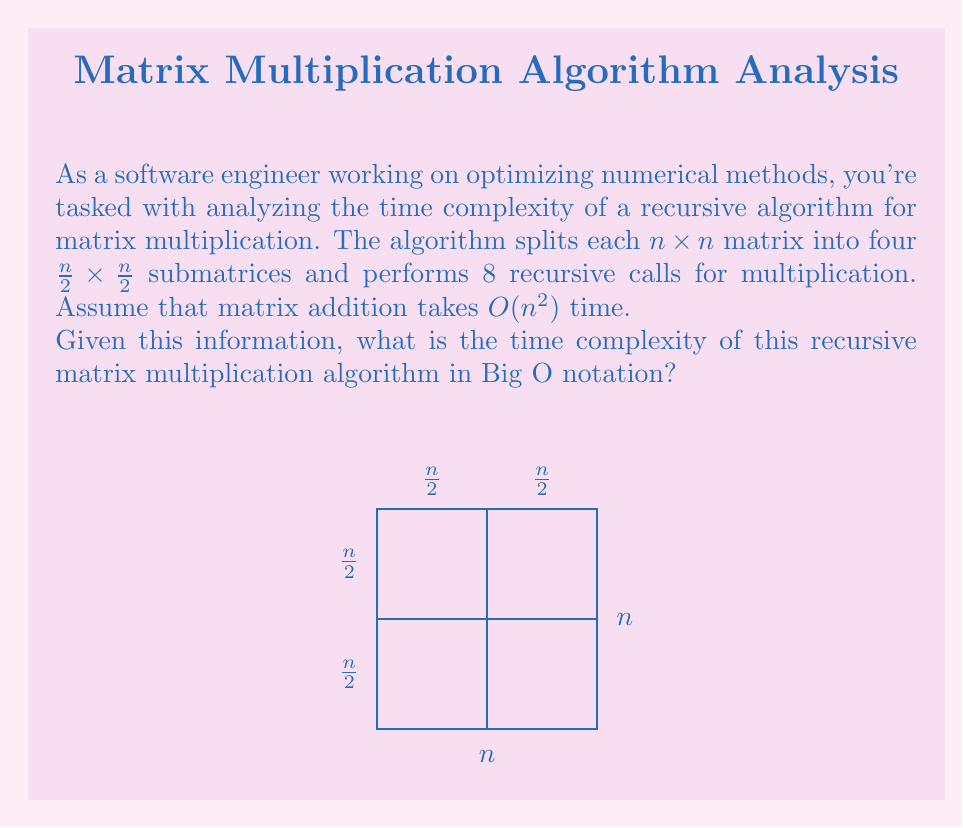Show me your answer to this math problem. To analyze the time complexity of this recursive matrix multiplication algorithm, we'll use the Master Theorem. Let's break it down step-by-step:

1) First, we need to identify the recurrence relation. Let $T(n)$ be the time complexity for multiplying two $n \times n$ matrices:

   $T(n) = 8T(\frac{n}{2}) + O(n^2)$

   Here, 8 comes from the number of recursive calls, $\frac{n}{2}$ is the size of each submatrix, and $O(n^2)$ is the time for matrix addition.

2) Now, let's compare this to the general form of the Master Theorem:

   $T(n) = aT(\frac{n}{b}) + f(n)$

   Where $a \geq 1$, $b > 1$, and $f(n)$ is a positive function.

3) In our case:
   $a = 8$
   $b = 2$
   $f(n) = O(n^2)$

4) The next step is to compare $n^{\log_b a}$ with $f(n)$:

   $n^{\log_b a} = n^{\log_2 8} = n^3$

5) Since $f(n) = O(n^2)$ and $n^{\log_b a} = n^3$, we have:

   $f(n) = O(n^{\log_b a - \epsilon})$ for some $\epsilon > 0$

   This corresponds to Case 1 of the Master Theorem.

6) According to Case 1, the solution to the recurrence is:

   $T(n) = \Theta(n^{\log_b a}) = \Theta(n^{\log_2 8}) = \Theta(n^3)$

Therefore, the time complexity of this recursive matrix multiplication algorithm is $\Theta(n^3)$.
Answer: $\Theta(n^3)$ 